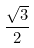<formula> <loc_0><loc_0><loc_500><loc_500>\frac { \sqrt { 3 } } { 2 }</formula> 